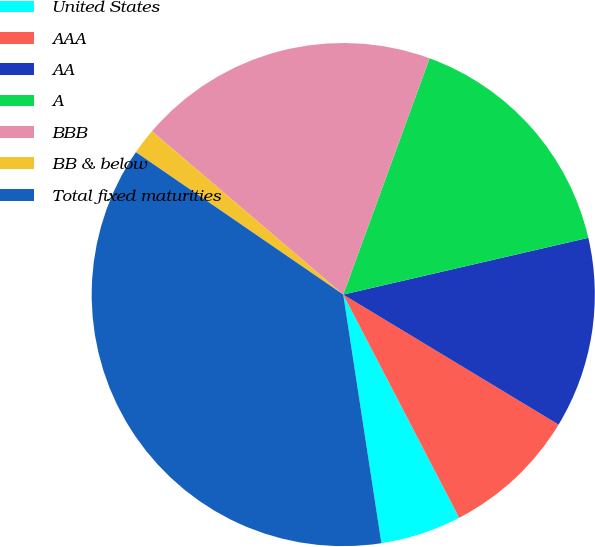<chart> <loc_0><loc_0><loc_500><loc_500><pie_chart><fcel>United States<fcel>AAA<fcel>AA<fcel>A<fcel>BBB<fcel>BB & below<fcel>Total fixed maturities<nl><fcel>5.2%<fcel>8.73%<fcel>12.27%<fcel>15.8%<fcel>19.33%<fcel>1.67%<fcel>37.0%<nl></chart> 